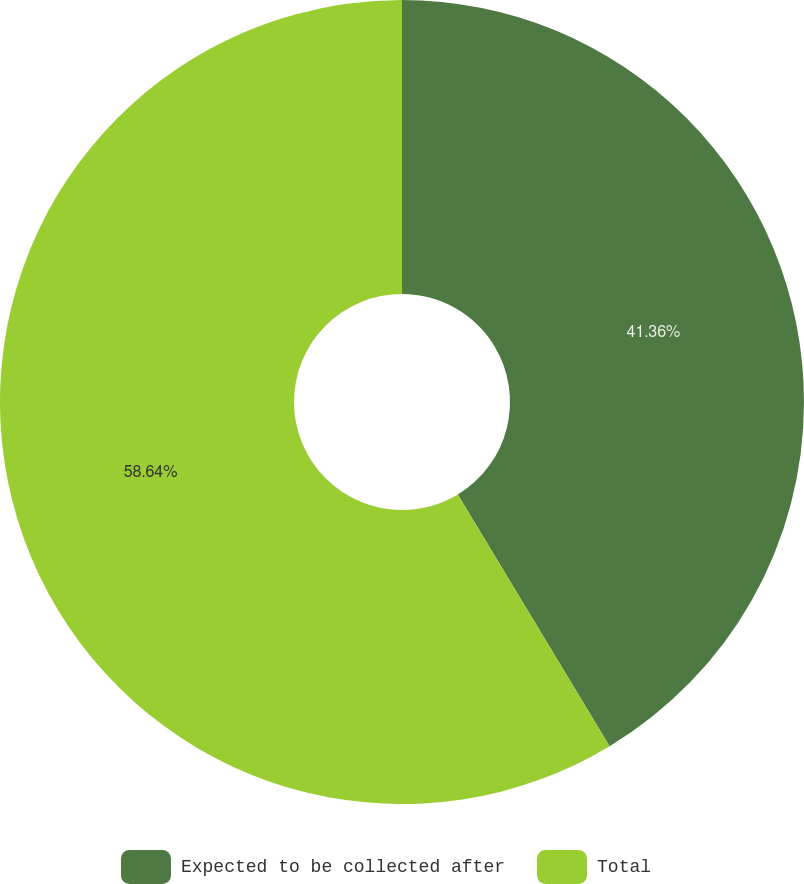Convert chart. <chart><loc_0><loc_0><loc_500><loc_500><pie_chart><fcel>Expected to be collected after<fcel>Total<nl><fcel>41.36%<fcel>58.64%<nl></chart> 